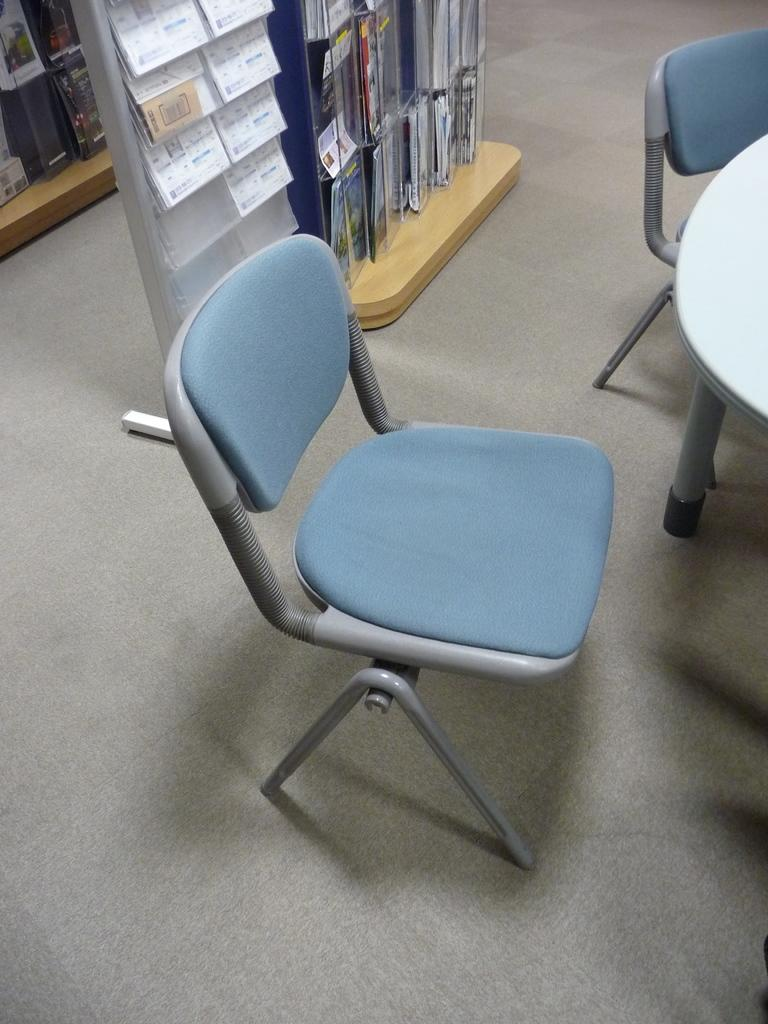How many chairs are visible in the image? There are two chairs in the image. What other piece of furniture is present in the image? There is a table in the image. What can be seen on the shelves in the image? Books are arranged in shelves in the image. What type of surface is mentioned in the image? There are other objects attached to a wooden surface. Can you see any veins on the wooden surface in the image? There is no mention of veins on the wooden surface in the image. Is there a skateboard visible on the table in the image? There is no skateboard present in the image. 